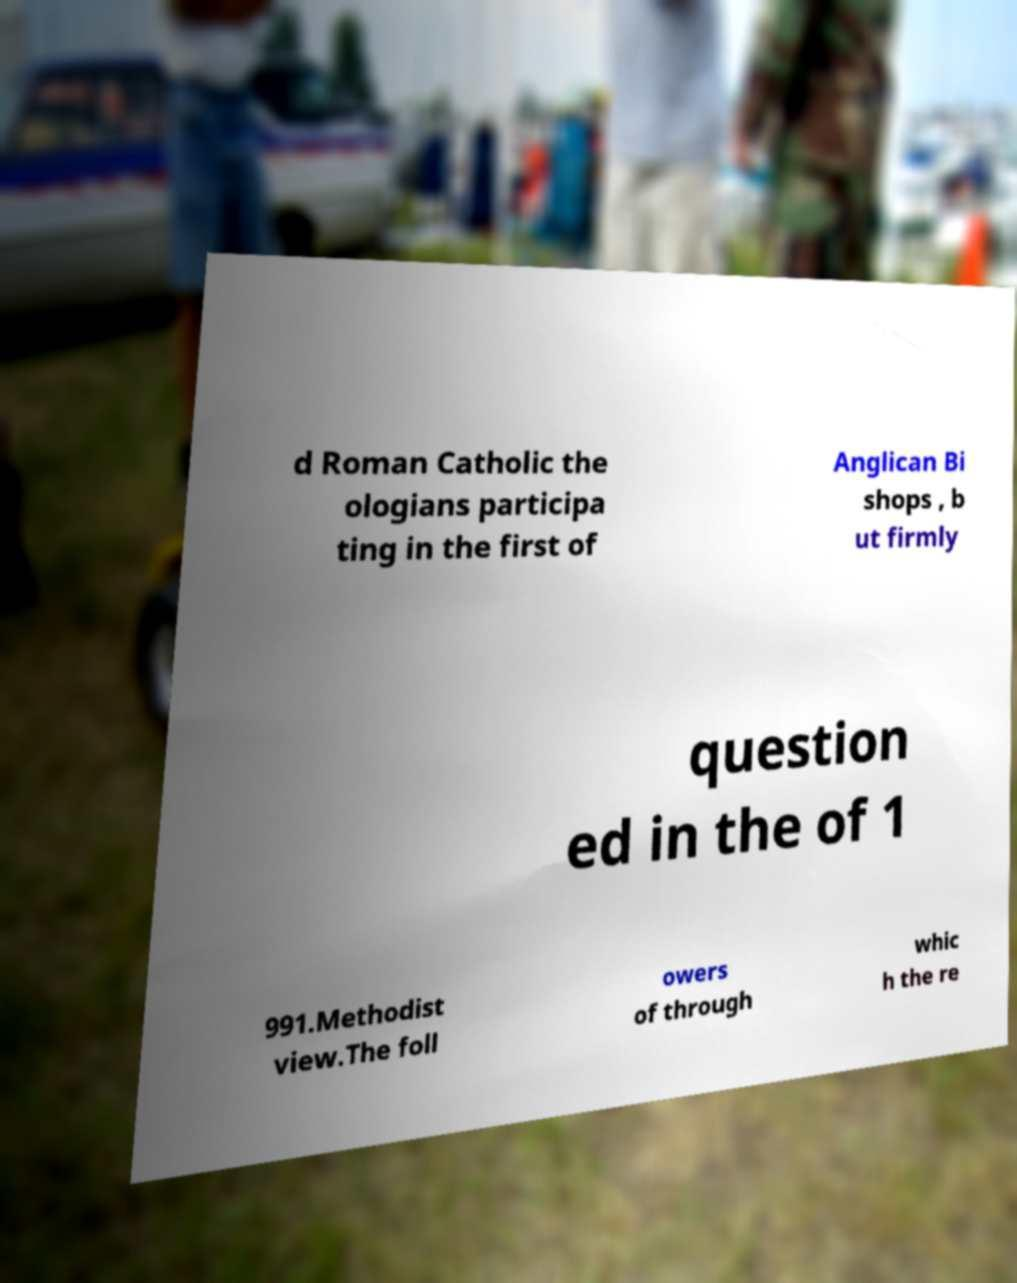Could you assist in decoding the text presented in this image and type it out clearly? d Roman Catholic the ologians participa ting in the first of Anglican Bi shops , b ut firmly question ed in the of 1 991.Methodist view.The foll owers of through whic h the re 